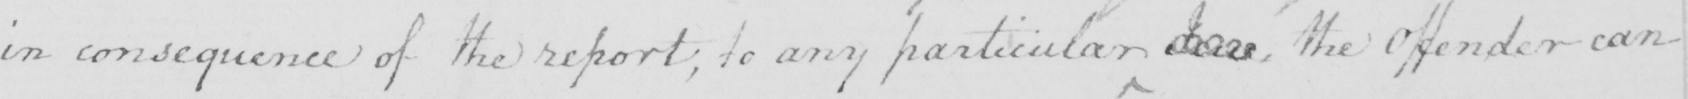What is written in this line of handwriting? in consequence of the report , to any particular Jew , the Offender can 